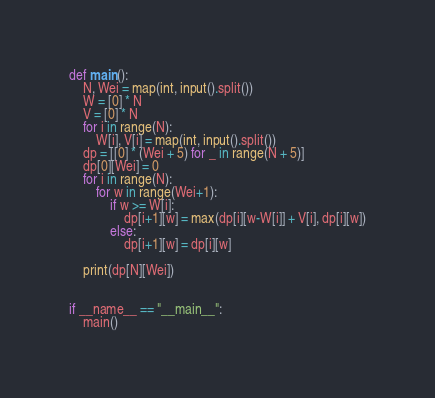Convert code to text. <code><loc_0><loc_0><loc_500><loc_500><_Python_>def main():
    N, Wei = map(int, input().split())
    W = [0] * N
    V = [0] * N
    for i in range(N):
        W[i], V[i] = map(int, input().split())
    dp = [[0] * (Wei + 5) for _ in range(N + 5)]
    dp[0][Wei] = 0
    for i in range(N):
        for w in range(Wei+1):
            if w >= W[i]:
                dp[i+1][w] = max(dp[i][w-W[i]] + V[i], dp[i][w])
            else:
                dp[i+1][w] = dp[i][w]

    print(dp[N][Wei])


if __name__ == "__main__":
    main()</code> 